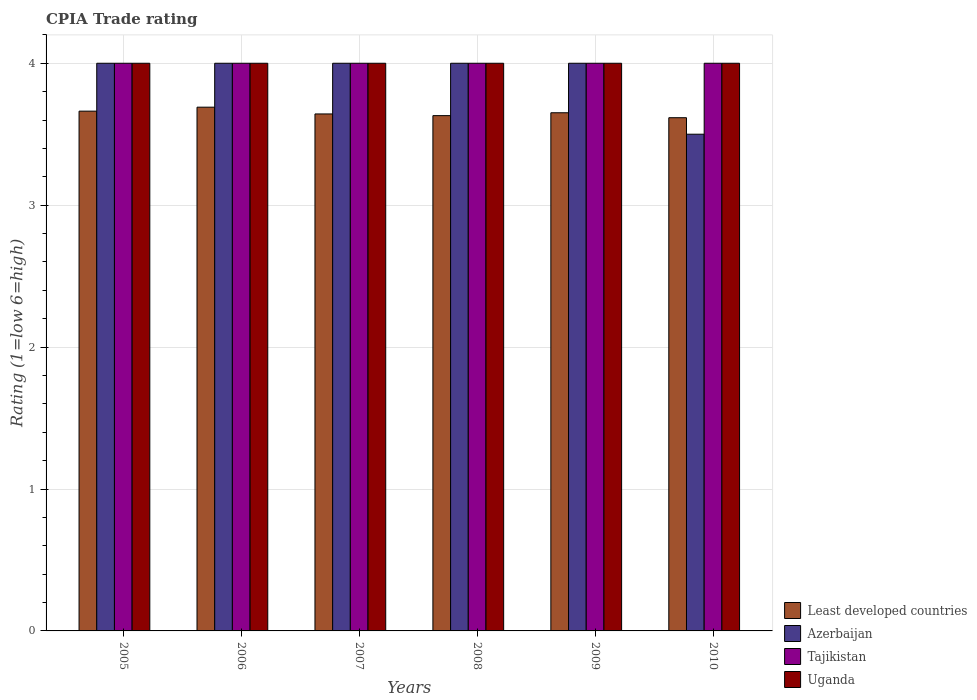How many groups of bars are there?
Your answer should be compact. 6. How many bars are there on the 1st tick from the right?
Ensure brevity in your answer.  4. What is the label of the 3rd group of bars from the left?
Provide a short and direct response. 2007. In how many cases, is the number of bars for a given year not equal to the number of legend labels?
Make the answer very short. 0. Across all years, what is the maximum CPIA rating in Least developed countries?
Offer a terse response. 3.69. In which year was the CPIA rating in Uganda minimum?
Make the answer very short. 2005. What is the total CPIA rating in Azerbaijan in the graph?
Provide a succinct answer. 23.5. What is the difference between the CPIA rating in Tajikistan in 2005 and that in 2009?
Make the answer very short. 0. What is the difference between the CPIA rating in Uganda in 2007 and the CPIA rating in Tajikistan in 2005?
Your answer should be very brief. 0. What is the average CPIA rating in Tajikistan per year?
Give a very brief answer. 4. In the year 2007, what is the difference between the CPIA rating in Least developed countries and CPIA rating in Tajikistan?
Give a very brief answer. -0.36. In how many years, is the CPIA rating in Azerbaijan greater than 2.2?
Provide a succinct answer. 6. What is the ratio of the CPIA rating in Least developed countries in 2005 to that in 2007?
Ensure brevity in your answer.  1.01. Is the CPIA rating in Uganda in 2009 less than that in 2010?
Ensure brevity in your answer.  No. What is the difference between the highest and the second highest CPIA rating in Least developed countries?
Give a very brief answer. 0.03. What is the difference between the highest and the lowest CPIA rating in Azerbaijan?
Ensure brevity in your answer.  0.5. In how many years, is the CPIA rating in Least developed countries greater than the average CPIA rating in Least developed countries taken over all years?
Offer a very short reply. 3. Is it the case that in every year, the sum of the CPIA rating in Uganda and CPIA rating in Least developed countries is greater than the sum of CPIA rating in Azerbaijan and CPIA rating in Tajikistan?
Offer a very short reply. No. What does the 4th bar from the left in 2005 represents?
Keep it short and to the point. Uganda. What does the 3rd bar from the right in 2007 represents?
Your answer should be compact. Azerbaijan. Is it the case that in every year, the sum of the CPIA rating in Uganda and CPIA rating in Least developed countries is greater than the CPIA rating in Tajikistan?
Ensure brevity in your answer.  Yes. How many bars are there?
Provide a short and direct response. 24. How many years are there in the graph?
Provide a succinct answer. 6. What is the difference between two consecutive major ticks on the Y-axis?
Your answer should be very brief. 1. Does the graph contain any zero values?
Your answer should be very brief. No. How many legend labels are there?
Your answer should be compact. 4. How are the legend labels stacked?
Offer a very short reply. Vertical. What is the title of the graph?
Provide a short and direct response. CPIA Trade rating. Does "Bulgaria" appear as one of the legend labels in the graph?
Offer a terse response. No. What is the label or title of the X-axis?
Your response must be concise. Years. What is the Rating (1=low 6=high) in Least developed countries in 2005?
Make the answer very short. 3.66. What is the Rating (1=low 6=high) in Azerbaijan in 2005?
Ensure brevity in your answer.  4. What is the Rating (1=low 6=high) of Tajikistan in 2005?
Offer a very short reply. 4. What is the Rating (1=low 6=high) in Least developed countries in 2006?
Your answer should be very brief. 3.69. What is the Rating (1=low 6=high) of Azerbaijan in 2006?
Your response must be concise. 4. What is the Rating (1=low 6=high) in Tajikistan in 2006?
Your response must be concise. 4. What is the Rating (1=low 6=high) in Least developed countries in 2007?
Your answer should be very brief. 3.64. What is the Rating (1=low 6=high) of Tajikistan in 2007?
Ensure brevity in your answer.  4. What is the Rating (1=low 6=high) of Least developed countries in 2008?
Make the answer very short. 3.63. What is the Rating (1=low 6=high) of Uganda in 2008?
Give a very brief answer. 4. What is the Rating (1=low 6=high) in Least developed countries in 2009?
Your response must be concise. 3.65. What is the Rating (1=low 6=high) in Tajikistan in 2009?
Provide a succinct answer. 4. What is the Rating (1=low 6=high) in Least developed countries in 2010?
Ensure brevity in your answer.  3.62. What is the Rating (1=low 6=high) of Azerbaijan in 2010?
Keep it short and to the point. 3.5. What is the Rating (1=low 6=high) of Tajikistan in 2010?
Your response must be concise. 4. What is the Rating (1=low 6=high) of Uganda in 2010?
Your answer should be very brief. 4. Across all years, what is the maximum Rating (1=low 6=high) of Least developed countries?
Your response must be concise. 3.69. Across all years, what is the maximum Rating (1=low 6=high) in Tajikistan?
Offer a terse response. 4. Across all years, what is the maximum Rating (1=low 6=high) of Uganda?
Keep it short and to the point. 4. Across all years, what is the minimum Rating (1=low 6=high) of Least developed countries?
Ensure brevity in your answer.  3.62. Across all years, what is the minimum Rating (1=low 6=high) of Uganda?
Offer a terse response. 4. What is the total Rating (1=low 6=high) of Least developed countries in the graph?
Keep it short and to the point. 21.89. What is the total Rating (1=low 6=high) of Azerbaijan in the graph?
Give a very brief answer. 23.5. What is the total Rating (1=low 6=high) in Tajikistan in the graph?
Your response must be concise. 24. What is the total Rating (1=low 6=high) in Uganda in the graph?
Your answer should be very brief. 24. What is the difference between the Rating (1=low 6=high) in Least developed countries in 2005 and that in 2006?
Your answer should be compact. -0.03. What is the difference between the Rating (1=low 6=high) of Least developed countries in 2005 and that in 2007?
Your response must be concise. 0.02. What is the difference between the Rating (1=low 6=high) in Azerbaijan in 2005 and that in 2007?
Offer a terse response. 0. What is the difference between the Rating (1=low 6=high) in Least developed countries in 2005 and that in 2008?
Provide a succinct answer. 0.03. What is the difference between the Rating (1=low 6=high) in Azerbaijan in 2005 and that in 2008?
Make the answer very short. 0. What is the difference between the Rating (1=low 6=high) of Least developed countries in 2005 and that in 2009?
Ensure brevity in your answer.  0.01. What is the difference between the Rating (1=low 6=high) in Azerbaijan in 2005 and that in 2009?
Offer a very short reply. 0. What is the difference between the Rating (1=low 6=high) in Tajikistan in 2005 and that in 2009?
Your answer should be very brief. 0. What is the difference between the Rating (1=low 6=high) of Uganda in 2005 and that in 2009?
Your answer should be compact. 0. What is the difference between the Rating (1=low 6=high) of Least developed countries in 2005 and that in 2010?
Your answer should be compact. 0.05. What is the difference between the Rating (1=low 6=high) in Azerbaijan in 2005 and that in 2010?
Your answer should be compact. 0.5. What is the difference between the Rating (1=low 6=high) in Uganda in 2005 and that in 2010?
Provide a short and direct response. 0. What is the difference between the Rating (1=low 6=high) of Least developed countries in 2006 and that in 2007?
Give a very brief answer. 0.05. What is the difference between the Rating (1=low 6=high) in Azerbaijan in 2006 and that in 2007?
Provide a short and direct response. 0. What is the difference between the Rating (1=low 6=high) in Least developed countries in 2006 and that in 2008?
Keep it short and to the point. 0.06. What is the difference between the Rating (1=low 6=high) of Tajikistan in 2006 and that in 2008?
Provide a short and direct response. 0. What is the difference between the Rating (1=low 6=high) of Least developed countries in 2006 and that in 2009?
Offer a very short reply. 0.04. What is the difference between the Rating (1=low 6=high) in Uganda in 2006 and that in 2009?
Offer a terse response. 0. What is the difference between the Rating (1=low 6=high) of Least developed countries in 2006 and that in 2010?
Provide a short and direct response. 0.07. What is the difference between the Rating (1=low 6=high) of Azerbaijan in 2006 and that in 2010?
Make the answer very short. 0.5. What is the difference between the Rating (1=low 6=high) of Tajikistan in 2006 and that in 2010?
Provide a short and direct response. 0. What is the difference between the Rating (1=low 6=high) of Uganda in 2006 and that in 2010?
Make the answer very short. 0. What is the difference between the Rating (1=low 6=high) in Least developed countries in 2007 and that in 2008?
Make the answer very short. 0.01. What is the difference between the Rating (1=low 6=high) of Least developed countries in 2007 and that in 2009?
Provide a succinct answer. -0.01. What is the difference between the Rating (1=low 6=high) in Azerbaijan in 2007 and that in 2009?
Your answer should be very brief. 0. What is the difference between the Rating (1=low 6=high) of Tajikistan in 2007 and that in 2009?
Give a very brief answer. 0. What is the difference between the Rating (1=low 6=high) in Uganda in 2007 and that in 2009?
Provide a succinct answer. 0. What is the difference between the Rating (1=low 6=high) in Least developed countries in 2007 and that in 2010?
Offer a terse response. 0.03. What is the difference between the Rating (1=low 6=high) of Azerbaijan in 2007 and that in 2010?
Your response must be concise. 0.5. What is the difference between the Rating (1=low 6=high) in Tajikistan in 2007 and that in 2010?
Provide a succinct answer. 0. What is the difference between the Rating (1=low 6=high) of Least developed countries in 2008 and that in 2009?
Ensure brevity in your answer.  -0.02. What is the difference between the Rating (1=low 6=high) of Least developed countries in 2008 and that in 2010?
Offer a terse response. 0.01. What is the difference between the Rating (1=low 6=high) in Least developed countries in 2009 and that in 2010?
Your answer should be compact. 0.03. What is the difference between the Rating (1=low 6=high) of Azerbaijan in 2009 and that in 2010?
Your answer should be very brief. 0.5. What is the difference between the Rating (1=low 6=high) in Tajikistan in 2009 and that in 2010?
Make the answer very short. 0. What is the difference between the Rating (1=low 6=high) of Least developed countries in 2005 and the Rating (1=low 6=high) of Azerbaijan in 2006?
Give a very brief answer. -0.34. What is the difference between the Rating (1=low 6=high) in Least developed countries in 2005 and the Rating (1=low 6=high) in Tajikistan in 2006?
Make the answer very short. -0.34. What is the difference between the Rating (1=low 6=high) in Least developed countries in 2005 and the Rating (1=low 6=high) in Uganda in 2006?
Your answer should be very brief. -0.34. What is the difference between the Rating (1=low 6=high) of Azerbaijan in 2005 and the Rating (1=low 6=high) of Tajikistan in 2006?
Make the answer very short. 0. What is the difference between the Rating (1=low 6=high) of Azerbaijan in 2005 and the Rating (1=low 6=high) of Uganda in 2006?
Ensure brevity in your answer.  0. What is the difference between the Rating (1=low 6=high) of Tajikistan in 2005 and the Rating (1=low 6=high) of Uganda in 2006?
Give a very brief answer. 0. What is the difference between the Rating (1=low 6=high) in Least developed countries in 2005 and the Rating (1=low 6=high) in Azerbaijan in 2007?
Offer a terse response. -0.34. What is the difference between the Rating (1=low 6=high) in Least developed countries in 2005 and the Rating (1=low 6=high) in Tajikistan in 2007?
Your response must be concise. -0.34. What is the difference between the Rating (1=low 6=high) in Least developed countries in 2005 and the Rating (1=low 6=high) in Uganda in 2007?
Give a very brief answer. -0.34. What is the difference between the Rating (1=low 6=high) of Azerbaijan in 2005 and the Rating (1=low 6=high) of Tajikistan in 2007?
Make the answer very short. 0. What is the difference between the Rating (1=low 6=high) in Azerbaijan in 2005 and the Rating (1=low 6=high) in Uganda in 2007?
Give a very brief answer. 0. What is the difference between the Rating (1=low 6=high) of Least developed countries in 2005 and the Rating (1=low 6=high) of Azerbaijan in 2008?
Ensure brevity in your answer.  -0.34. What is the difference between the Rating (1=low 6=high) in Least developed countries in 2005 and the Rating (1=low 6=high) in Tajikistan in 2008?
Your answer should be very brief. -0.34. What is the difference between the Rating (1=low 6=high) in Least developed countries in 2005 and the Rating (1=low 6=high) in Uganda in 2008?
Make the answer very short. -0.34. What is the difference between the Rating (1=low 6=high) of Azerbaijan in 2005 and the Rating (1=low 6=high) of Uganda in 2008?
Give a very brief answer. 0. What is the difference between the Rating (1=low 6=high) in Tajikistan in 2005 and the Rating (1=low 6=high) in Uganda in 2008?
Offer a terse response. 0. What is the difference between the Rating (1=low 6=high) in Least developed countries in 2005 and the Rating (1=low 6=high) in Azerbaijan in 2009?
Your response must be concise. -0.34. What is the difference between the Rating (1=low 6=high) in Least developed countries in 2005 and the Rating (1=low 6=high) in Tajikistan in 2009?
Offer a very short reply. -0.34. What is the difference between the Rating (1=low 6=high) of Least developed countries in 2005 and the Rating (1=low 6=high) of Uganda in 2009?
Keep it short and to the point. -0.34. What is the difference between the Rating (1=low 6=high) of Tajikistan in 2005 and the Rating (1=low 6=high) of Uganda in 2009?
Give a very brief answer. 0. What is the difference between the Rating (1=low 6=high) of Least developed countries in 2005 and the Rating (1=low 6=high) of Azerbaijan in 2010?
Offer a terse response. 0.16. What is the difference between the Rating (1=low 6=high) in Least developed countries in 2005 and the Rating (1=low 6=high) in Tajikistan in 2010?
Offer a very short reply. -0.34. What is the difference between the Rating (1=low 6=high) in Least developed countries in 2005 and the Rating (1=low 6=high) in Uganda in 2010?
Offer a terse response. -0.34. What is the difference between the Rating (1=low 6=high) in Azerbaijan in 2005 and the Rating (1=low 6=high) in Tajikistan in 2010?
Offer a terse response. 0. What is the difference between the Rating (1=low 6=high) in Azerbaijan in 2005 and the Rating (1=low 6=high) in Uganda in 2010?
Offer a terse response. 0. What is the difference between the Rating (1=low 6=high) of Tajikistan in 2005 and the Rating (1=low 6=high) of Uganda in 2010?
Provide a short and direct response. 0. What is the difference between the Rating (1=low 6=high) of Least developed countries in 2006 and the Rating (1=low 6=high) of Azerbaijan in 2007?
Keep it short and to the point. -0.31. What is the difference between the Rating (1=low 6=high) in Least developed countries in 2006 and the Rating (1=low 6=high) in Tajikistan in 2007?
Your answer should be compact. -0.31. What is the difference between the Rating (1=low 6=high) in Least developed countries in 2006 and the Rating (1=low 6=high) in Uganda in 2007?
Provide a succinct answer. -0.31. What is the difference between the Rating (1=low 6=high) in Azerbaijan in 2006 and the Rating (1=low 6=high) in Tajikistan in 2007?
Your answer should be compact. 0. What is the difference between the Rating (1=low 6=high) in Azerbaijan in 2006 and the Rating (1=low 6=high) in Uganda in 2007?
Your response must be concise. 0. What is the difference between the Rating (1=low 6=high) of Tajikistan in 2006 and the Rating (1=low 6=high) of Uganda in 2007?
Make the answer very short. 0. What is the difference between the Rating (1=low 6=high) in Least developed countries in 2006 and the Rating (1=low 6=high) in Azerbaijan in 2008?
Offer a terse response. -0.31. What is the difference between the Rating (1=low 6=high) of Least developed countries in 2006 and the Rating (1=low 6=high) of Tajikistan in 2008?
Your answer should be compact. -0.31. What is the difference between the Rating (1=low 6=high) of Least developed countries in 2006 and the Rating (1=low 6=high) of Uganda in 2008?
Provide a succinct answer. -0.31. What is the difference between the Rating (1=low 6=high) in Tajikistan in 2006 and the Rating (1=low 6=high) in Uganda in 2008?
Ensure brevity in your answer.  0. What is the difference between the Rating (1=low 6=high) of Least developed countries in 2006 and the Rating (1=low 6=high) of Azerbaijan in 2009?
Make the answer very short. -0.31. What is the difference between the Rating (1=low 6=high) in Least developed countries in 2006 and the Rating (1=low 6=high) in Tajikistan in 2009?
Offer a terse response. -0.31. What is the difference between the Rating (1=low 6=high) in Least developed countries in 2006 and the Rating (1=low 6=high) in Uganda in 2009?
Offer a terse response. -0.31. What is the difference between the Rating (1=low 6=high) of Azerbaijan in 2006 and the Rating (1=low 6=high) of Uganda in 2009?
Your response must be concise. 0. What is the difference between the Rating (1=low 6=high) of Tajikistan in 2006 and the Rating (1=low 6=high) of Uganda in 2009?
Your answer should be compact. 0. What is the difference between the Rating (1=low 6=high) in Least developed countries in 2006 and the Rating (1=low 6=high) in Azerbaijan in 2010?
Provide a short and direct response. 0.19. What is the difference between the Rating (1=low 6=high) of Least developed countries in 2006 and the Rating (1=low 6=high) of Tajikistan in 2010?
Make the answer very short. -0.31. What is the difference between the Rating (1=low 6=high) of Least developed countries in 2006 and the Rating (1=low 6=high) of Uganda in 2010?
Offer a terse response. -0.31. What is the difference between the Rating (1=low 6=high) of Azerbaijan in 2006 and the Rating (1=low 6=high) of Uganda in 2010?
Your response must be concise. 0. What is the difference between the Rating (1=low 6=high) of Least developed countries in 2007 and the Rating (1=low 6=high) of Azerbaijan in 2008?
Your response must be concise. -0.36. What is the difference between the Rating (1=low 6=high) in Least developed countries in 2007 and the Rating (1=low 6=high) in Tajikistan in 2008?
Your answer should be compact. -0.36. What is the difference between the Rating (1=low 6=high) of Least developed countries in 2007 and the Rating (1=low 6=high) of Uganda in 2008?
Give a very brief answer. -0.36. What is the difference between the Rating (1=low 6=high) of Tajikistan in 2007 and the Rating (1=low 6=high) of Uganda in 2008?
Provide a short and direct response. 0. What is the difference between the Rating (1=low 6=high) in Least developed countries in 2007 and the Rating (1=low 6=high) in Azerbaijan in 2009?
Make the answer very short. -0.36. What is the difference between the Rating (1=low 6=high) of Least developed countries in 2007 and the Rating (1=low 6=high) of Tajikistan in 2009?
Make the answer very short. -0.36. What is the difference between the Rating (1=low 6=high) of Least developed countries in 2007 and the Rating (1=low 6=high) of Uganda in 2009?
Provide a succinct answer. -0.36. What is the difference between the Rating (1=low 6=high) of Least developed countries in 2007 and the Rating (1=low 6=high) of Azerbaijan in 2010?
Your response must be concise. 0.14. What is the difference between the Rating (1=low 6=high) of Least developed countries in 2007 and the Rating (1=low 6=high) of Tajikistan in 2010?
Ensure brevity in your answer.  -0.36. What is the difference between the Rating (1=low 6=high) in Least developed countries in 2007 and the Rating (1=low 6=high) in Uganda in 2010?
Offer a terse response. -0.36. What is the difference between the Rating (1=low 6=high) of Azerbaijan in 2007 and the Rating (1=low 6=high) of Tajikistan in 2010?
Your answer should be compact. 0. What is the difference between the Rating (1=low 6=high) in Azerbaijan in 2007 and the Rating (1=low 6=high) in Uganda in 2010?
Give a very brief answer. 0. What is the difference between the Rating (1=low 6=high) in Tajikistan in 2007 and the Rating (1=low 6=high) in Uganda in 2010?
Make the answer very short. 0. What is the difference between the Rating (1=low 6=high) in Least developed countries in 2008 and the Rating (1=low 6=high) in Azerbaijan in 2009?
Your response must be concise. -0.37. What is the difference between the Rating (1=low 6=high) in Least developed countries in 2008 and the Rating (1=low 6=high) in Tajikistan in 2009?
Ensure brevity in your answer.  -0.37. What is the difference between the Rating (1=low 6=high) of Least developed countries in 2008 and the Rating (1=low 6=high) of Uganda in 2009?
Your response must be concise. -0.37. What is the difference between the Rating (1=low 6=high) of Tajikistan in 2008 and the Rating (1=low 6=high) of Uganda in 2009?
Ensure brevity in your answer.  0. What is the difference between the Rating (1=low 6=high) of Least developed countries in 2008 and the Rating (1=low 6=high) of Azerbaijan in 2010?
Your answer should be very brief. 0.13. What is the difference between the Rating (1=low 6=high) in Least developed countries in 2008 and the Rating (1=low 6=high) in Tajikistan in 2010?
Your answer should be compact. -0.37. What is the difference between the Rating (1=low 6=high) of Least developed countries in 2008 and the Rating (1=low 6=high) of Uganda in 2010?
Ensure brevity in your answer.  -0.37. What is the difference between the Rating (1=low 6=high) of Azerbaijan in 2008 and the Rating (1=low 6=high) of Tajikistan in 2010?
Your answer should be compact. 0. What is the difference between the Rating (1=low 6=high) in Azerbaijan in 2008 and the Rating (1=low 6=high) in Uganda in 2010?
Make the answer very short. 0. What is the difference between the Rating (1=low 6=high) of Tajikistan in 2008 and the Rating (1=low 6=high) of Uganda in 2010?
Your response must be concise. 0. What is the difference between the Rating (1=low 6=high) of Least developed countries in 2009 and the Rating (1=low 6=high) of Azerbaijan in 2010?
Offer a terse response. 0.15. What is the difference between the Rating (1=low 6=high) of Least developed countries in 2009 and the Rating (1=low 6=high) of Tajikistan in 2010?
Provide a short and direct response. -0.35. What is the difference between the Rating (1=low 6=high) in Least developed countries in 2009 and the Rating (1=low 6=high) in Uganda in 2010?
Offer a terse response. -0.35. What is the difference between the Rating (1=low 6=high) in Azerbaijan in 2009 and the Rating (1=low 6=high) in Tajikistan in 2010?
Your answer should be compact. 0. What is the difference between the Rating (1=low 6=high) in Azerbaijan in 2009 and the Rating (1=low 6=high) in Uganda in 2010?
Give a very brief answer. 0. What is the average Rating (1=low 6=high) of Least developed countries per year?
Keep it short and to the point. 3.65. What is the average Rating (1=low 6=high) of Azerbaijan per year?
Your response must be concise. 3.92. What is the average Rating (1=low 6=high) of Tajikistan per year?
Your answer should be compact. 4. In the year 2005, what is the difference between the Rating (1=low 6=high) of Least developed countries and Rating (1=low 6=high) of Azerbaijan?
Ensure brevity in your answer.  -0.34. In the year 2005, what is the difference between the Rating (1=low 6=high) of Least developed countries and Rating (1=low 6=high) of Tajikistan?
Your answer should be very brief. -0.34. In the year 2005, what is the difference between the Rating (1=low 6=high) of Least developed countries and Rating (1=low 6=high) of Uganda?
Provide a succinct answer. -0.34. In the year 2005, what is the difference between the Rating (1=low 6=high) of Tajikistan and Rating (1=low 6=high) of Uganda?
Your response must be concise. 0. In the year 2006, what is the difference between the Rating (1=low 6=high) in Least developed countries and Rating (1=low 6=high) in Azerbaijan?
Make the answer very short. -0.31. In the year 2006, what is the difference between the Rating (1=low 6=high) in Least developed countries and Rating (1=low 6=high) in Tajikistan?
Offer a very short reply. -0.31. In the year 2006, what is the difference between the Rating (1=low 6=high) of Least developed countries and Rating (1=low 6=high) of Uganda?
Provide a short and direct response. -0.31. In the year 2006, what is the difference between the Rating (1=low 6=high) of Azerbaijan and Rating (1=low 6=high) of Tajikistan?
Your answer should be compact. 0. In the year 2007, what is the difference between the Rating (1=low 6=high) in Least developed countries and Rating (1=low 6=high) in Azerbaijan?
Provide a short and direct response. -0.36. In the year 2007, what is the difference between the Rating (1=low 6=high) in Least developed countries and Rating (1=low 6=high) in Tajikistan?
Make the answer very short. -0.36. In the year 2007, what is the difference between the Rating (1=low 6=high) in Least developed countries and Rating (1=low 6=high) in Uganda?
Provide a succinct answer. -0.36. In the year 2007, what is the difference between the Rating (1=low 6=high) in Azerbaijan and Rating (1=low 6=high) in Uganda?
Offer a very short reply. 0. In the year 2007, what is the difference between the Rating (1=low 6=high) in Tajikistan and Rating (1=low 6=high) in Uganda?
Your response must be concise. 0. In the year 2008, what is the difference between the Rating (1=low 6=high) in Least developed countries and Rating (1=low 6=high) in Azerbaijan?
Provide a succinct answer. -0.37. In the year 2008, what is the difference between the Rating (1=low 6=high) in Least developed countries and Rating (1=low 6=high) in Tajikistan?
Provide a short and direct response. -0.37. In the year 2008, what is the difference between the Rating (1=low 6=high) of Least developed countries and Rating (1=low 6=high) of Uganda?
Your answer should be very brief. -0.37. In the year 2008, what is the difference between the Rating (1=low 6=high) of Azerbaijan and Rating (1=low 6=high) of Tajikistan?
Your answer should be compact. 0. In the year 2008, what is the difference between the Rating (1=low 6=high) of Azerbaijan and Rating (1=low 6=high) of Uganda?
Your answer should be very brief. 0. In the year 2009, what is the difference between the Rating (1=low 6=high) of Least developed countries and Rating (1=low 6=high) of Azerbaijan?
Give a very brief answer. -0.35. In the year 2009, what is the difference between the Rating (1=low 6=high) of Least developed countries and Rating (1=low 6=high) of Tajikistan?
Keep it short and to the point. -0.35. In the year 2009, what is the difference between the Rating (1=low 6=high) in Least developed countries and Rating (1=low 6=high) in Uganda?
Provide a short and direct response. -0.35. In the year 2009, what is the difference between the Rating (1=low 6=high) of Azerbaijan and Rating (1=low 6=high) of Uganda?
Offer a terse response. 0. In the year 2009, what is the difference between the Rating (1=low 6=high) of Tajikistan and Rating (1=low 6=high) of Uganda?
Provide a succinct answer. 0. In the year 2010, what is the difference between the Rating (1=low 6=high) in Least developed countries and Rating (1=low 6=high) in Azerbaijan?
Provide a short and direct response. 0.12. In the year 2010, what is the difference between the Rating (1=low 6=high) of Least developed countries and Rating (1=low 6=high) of Tajikistan?
Offer a terse response. -0.38. In the year 2010, what is the difference between the Rating (1=low 6=high) in Least developed countries and Rating (1=low 6=high) in Uganda?
Your response must be concise. -0.38. In the year 2010, what is the difference between the Rating (1=low 6=high) in Azerbaijan and Rating (1=low 6=high) in Tajikistan?
Keep it short and to the point. -0.5. What is the ratio of the Rating (1=low 6=high) in Azerbaijan in 2005 to that in 2006?
Your answer should be very brief. 1. What is the ratio of the Rating (1=low 6=high) of Uganda in 2005 to that in 2006?
Offer a very short reply. 1. What is the ratio of the Rating (1=low 6=high) of Least developed countries in 2005 to that in 2007?
Offer a very short reply. 1.01. What is the ratio of the Rating (1=low 6=high) of Tajikistan in 2005 to that in 2007?
Give a very brief answer. 1. What is the ratio of the Rating (1=low 6=high) in Uganda in 2005 to that in 2007?
Offer a very short reply. 1. What is the ratio of the Rating (1=low 6=high) of Least developed countries in 2005 to that in 2008?
Keep it short and to the point. 1.01. What is the ratio of the Rating (1=low 6=high) of Tajikistan in 2005 to that in 2008?
Provide a short and direct response. 1. What is the ratio of the Rating (1=low 6=high) of Azerbaijan in 2005 to that in 2009?
Your answer should be very brief. 1. What is the ratio of the Rating (1=low 6=high) of Tajikistan in 2005 to that in 2009?
Make the answer very short. 1. What is the ratio of the Rating (1=low 6=high) of Least developed countries in 2005 to that in 2010?
Your response must be concise. 1.01. What is the ratio of the Rating (1=low 6=high) in Tajikistan in 2005 to that in 2010?
Provide a succinct answer. 1. What is the ratio of the Rating (1=low 6=high) of Least developed countries in 2006 to that in 2007?
Your answer should be compact. 1.01. What is the ratio of the Rating (1=low 6=high) of Azerbaijan in 2006 to that in 2007?
Offer a very short reply. 1. What is the ratio of the Rating (1=low 6=high) of Uganda in 2006 to that in 2007?
Offer a very short reply. 1. What is the ratio of the Rating (1=low 6=high) of Least developed countries in 2006 to that in 2008?
Keep it short and to the point. 1.02. What is the ratio of the Rating (1=low 6=high) in Uganda in 2006 to that in 2008?
Provide a short and direct response. 1. What is the ratio of the Rating (1=low 6=high) in Least developed countries in 2006 to that in 2009?
Ensure brevity in your answer.  1.01. What is the ratio of the Rating (1=low 6=high) of Tajikistan in 2006 to that in 2009?
Ensure brevity in your answer.  1. What is the ratio of the Rating (1=low 6=high) of Uganda in 2006 to that in 2009?
Provide a succinct answer. 1. What is the ratio of the Rating (1=low 6=high) of Least developed countries in 2006 to that in 2010?
Provide a short and direct response. 1.02. What is the ratio of the Rating (1=low 6=high) in Azerbaijan in 2006 to that in 2010?
Offer a very short reply. 1.14. What is the ratio of the Rating (1=low 6=high) of Tajikistan in 2006 to that in 2010?
Provide a succinct answer. 1. What is the ratio of the Rating (1=low 6=high) of Azerbaijan in 2007 to that in 2008?
Keep it short and to the point. 1. What is the ratio of the Rating (1=low 6=high) of Tajikistan in 2007 to that in 2008?
Provide a succinct answer. 1. What is the ratio of the Rating (1=low 6=high) of Uganda in 2007 to that in 2008?
Offer a very short reply. 1. What is the ratio of the Rating (1=low 6=high) of Tajikistan in 2007 to that in 2009?
Keep it short and to the point. 1. What is the ratio of the Rating (1=low 6=high) of Uganda in 2007 to that in 2009?
Offer a terse response. 1. What is the ratio of the Rating (1=low 6=high) in Least developed countries in 2007 to that in 2010?
Ensure brevity in your answer.  1.01. What is the ratio of the Rating (1=low 6=high) of Azerbaijan in 2007 to that in 2010?
Give a very brief answer. 1.14. What is the ratio of the Rating (1=low 6=high) of Tajikistan in 2007 to that in 2010?
Give a very brief answer. 1. What is the ratio of the Rating (1=low 6=high) of Least developed countries in 2008 to that in 2009?
Your answer should be compact. 0.99. What is the ratio of the Rating (1=low 6=high) in Azerbaijan in 2008 to that in 2009?
Offer a terse response. 1. What is the ratio of the Rating (1=low 6=high) in Least developed countries in 2008 to that in 2010?
Make the answer very short. 1. What is the ratio of the Rating (1=low 6=high) in Least developed countries in 2009 to that in 2010?
Provide a succinct answer. 1.01. What is the ratio of the Rating (1=low 6=high) in Tajikistan in 2009 to that in 2010?
Give a very brief answer. 1. What is the difference between the highest and the second highest Rating (1=low 6=high) of Least developed countries?
Your response must be concise. 0.03. What is the difference between the highest and the second highest Rating (1=low 6=high) in Azerbaijan?
Offer a very short reply. 0. What is the difference between the highest and the lowest Rating (1=low 6=high) in Least developed countries?
Your response must be concise. 0.07. What is the difference between the highest and the lowest Rating (1=low 6=high) in Uganda?
Your answer should be very brief. 0. 